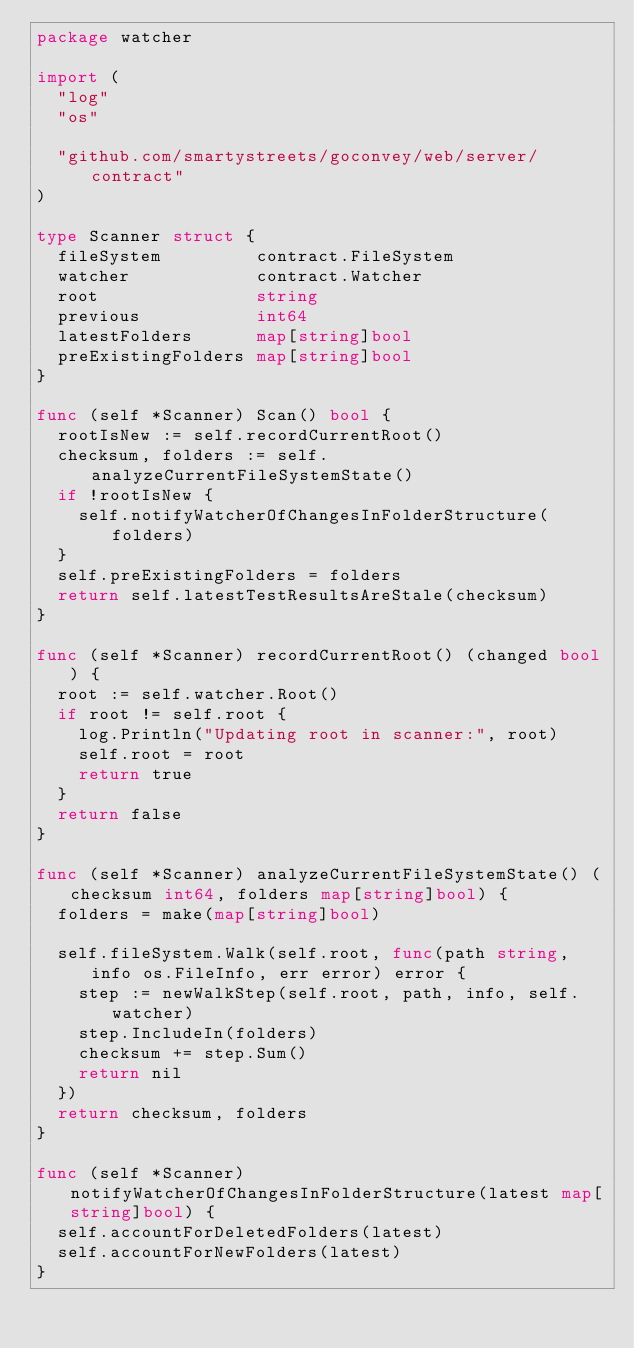Convert code to text. <code><loc_0><loc_0><loc_500><loc_500><_Go_>package watcher

import (
	"log"
	"os"

	"github.com/smartystreets/goconvey/web/server/contract"
)

type Scanner struct {
	fileSystem         contract.FileSystem
	watcher            contract.Watcher
	root               string
	previous           int64
	latestFolders      map[string]bool
	preExistingFolders map[string]bool
}

func (self *Scanner) Scan() bool {
	rootIsNew := self.recordCurrentRoot()
	checksum, folders := self.analyzeCurrentFileSystemState()
	if !rootIsNew {
		self.notifyWatcherOfChangesInFolderStructure(folders)
	}
	self.preExistingFolders = folders
	return self.latestTestResultsAreStale(checksum)
}

func (self *Scanner) recordCurrentRoot() (changed bool) {
	root := self.watcher.Root()
	if root != self.root {
		log.Println("Updating root in scanner:", root)
		self.root = root
		return true
	}
	return false
}

func (self *Scanner) analyzeCurrentFileSystemState() (checksum int64, folders map[string]bool) {
	folders = make(map[string]bool)

	self.fileSystem.Walk(self.root, func(path string, info os.FileInfo, err error) error {
		step := newWalkStep(self.root, path, info, self.watcher)
		step.IncludeIn(folders)
		checksum += step.Sum()
		return nil
	})
	return checksum, folders
}

func (self *Scanner) notifyWatcherOfChangesInFolderStructure(latest map[string]bool) {
	self.accountForDeletedFolders(latest)
	self.accountForNewFolders(latest)
}</code> 